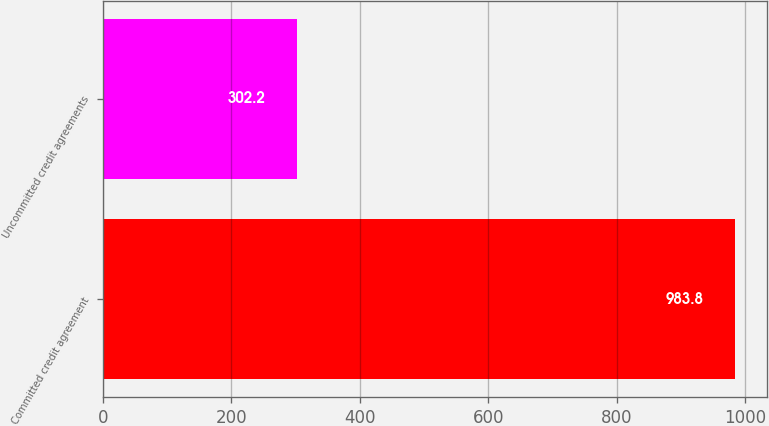<chart> <loc_0><loc_0><loc_500><loc_500><bar_chart><fcel>Committed credit agreement<fcel>Uncommitted credit agreements<nl><fcel>983.8<fcel>302.2<nl></chart> 